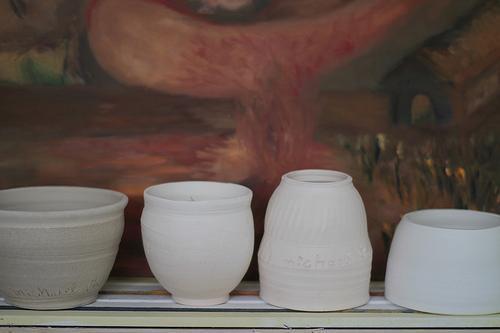How many paintings are there?
Give a very brief answer. 1. 